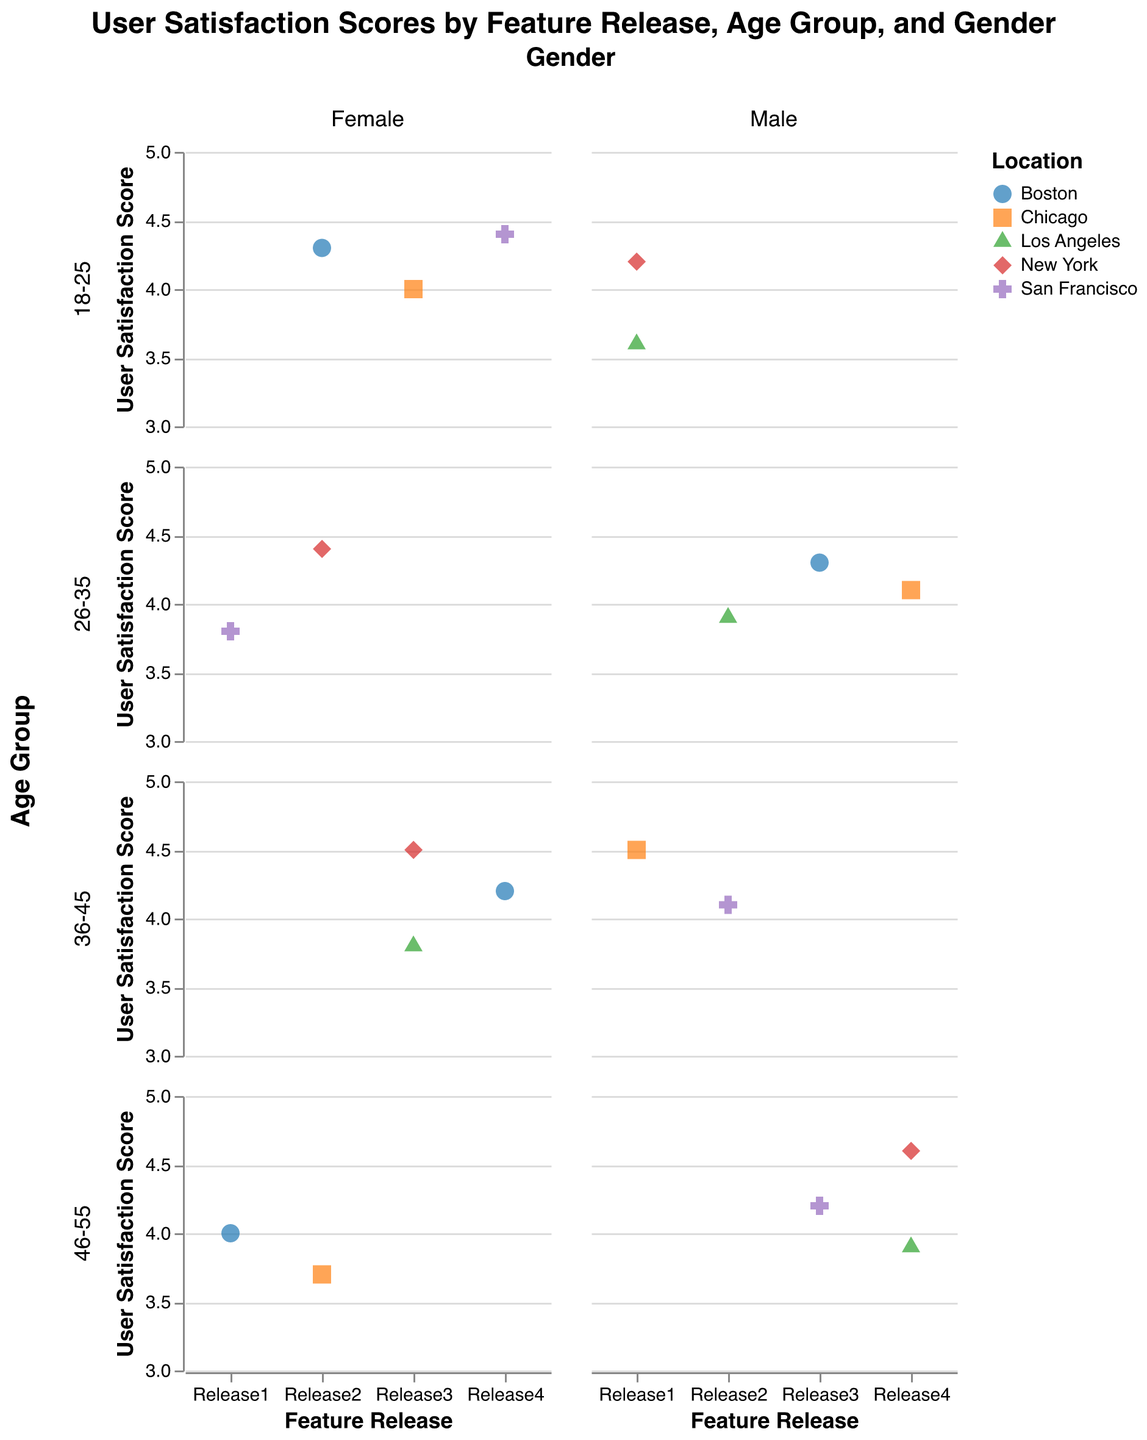What is the title of the figure? The title is usually found at the top of the figure and provides a summary of what the figure displays. The title here states, "User Satisfaction Scores by Feature Release, Age Group, and Gender."
Answer: User Satisfaction Scores by Feature Release, Age Group, and Gender What does the color of the points signify in the plots? The legend at the side of the plot indicates that the different colors represent various locations of the users.
Answer: Location How many feature releases are shown in the plots? By checking the x-axis in any of the subplots, there are labels indicating each feature release: Release1, Release2, Release3, and Release4. Counting these labels, we find there are 4 feature releases.
Answer: 4 Which gender and age group have the highest user satisfaction score for Release4? By looking at the subplots for Release4, we identify that the highest user satisfaction score is 4.6, which falls in the subplot for the 46-55 age group and for males.
Answer: Male, 46-55 What is the average user satisfaction score for females in the 26-35 age group across all feature releases? Sum the satisfaction scores for this group: 3.8 (Release1), 4.4 (Release2), 4.3 (Release3), and 4.1 (Release4). Total is 3.8 + 4.4 + 4.3 + 4.1 = 16.6, divided by 4, the average is 16.6/4.
Answer: 4.15 How does the satisfaction score of users in Los Angeles change from Release1 to Release4? Observe the points for the Los Angeles location across the four releases. The scores are 3.6 (Release1), 3.9 (Release2), 3.8 (Release3), 3.9 (Release4). The change indicates some variation but generally fluctuates around the same range.
Answer: Fluctuates Which age group shows the most consistent user satisfaction scores across different feature releases? By examining the variation in user satisfaction scores across the releases for each age group, the 26-35 age group exhibits the smallest variation (3.8, 4.4, 4.3, 4.1), which indicates consistency.
Answer: 26-35 Comparing the average satisfaction scores, which gender reports higher satisfaction for the 36-45 age group? Sum and average the satisfaction scores for males and females in the 36-45 age group: Males: (4.5 + 4.1 + 4.2) / 3 = 4.27 Females: (4.0 + 4.5 + 3.8) / 3 = 4.10. Males have a higher average score.
Answer: Male Which location has the highest satisfaction score for Release3 for the 18-25 age group? By locating the relevant subplot (18-25 age group) and identifying points corresponding to Release3, the highest score is 4.0, associated with Chicago.
Answer: Chicago 